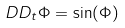Convert formula to latex. <formula><loc_0><loc_0><loc_500><loc_500>D D _ { t } \Phi = \sin ( \Phi )</formula> 